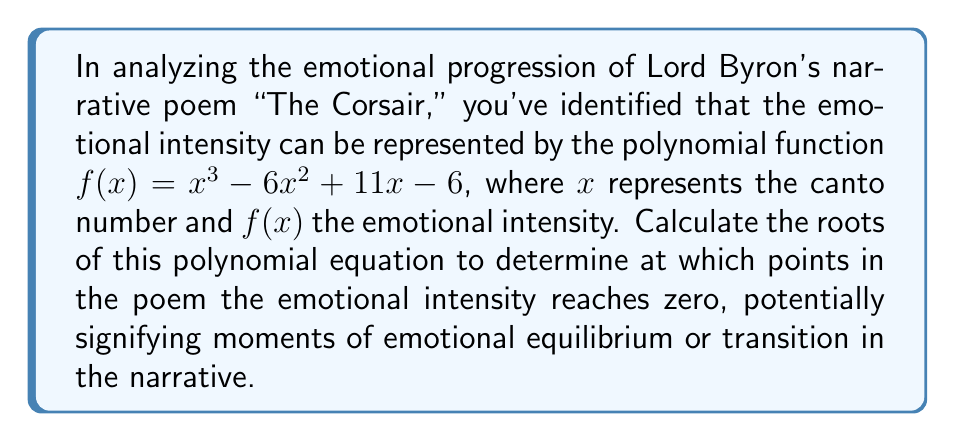Teach me how to tackle this problem. To find the roots of the polynomial $f(x) = x^3 - 6x^2 + 11x - 6$, we need to solve the equation $f(x) = 0$:

1) First, let's check if there are any rational roots using the rational root theorem. The possible rational roots are the factors of the constant term: $\pm 1, \pm 2, \pm 3, \pm 6$.

2) Testing these values, we find that $x = 1$ is a root:
   $f(1) = 1^3 - 6(1)^2 + 11(1) - 6 = 1 - 6 + 11 - 6 = 0$

3) Since $x = 1$ is a root, we can factor out $(x - 1)$:
   $f(x) = (x - 1)(x^2 - 5x + 6)$

4) Now we need to solve the quadratic equation $x^2 - 5x + 6 = 0$

5) Using the quadratic formula $x = \frac{-b \pm \sqrt{b^2 - 4ac}}{2a}$:
   $x = \frac{5 \pm \sqrt{25 - 24}}{2} = \frac{5 \pm 1}{2}$

6) This gives us the other two roots:
   $x = \frac{5 + 1}{2} = 3$ and $x = \frac{5 - 1}{2} = 2$

Therefore, the roots of the polynomial are $x = 1$, $x = 2$, and $x = 3$.
Answer: $x = 1, 2, 3$ 